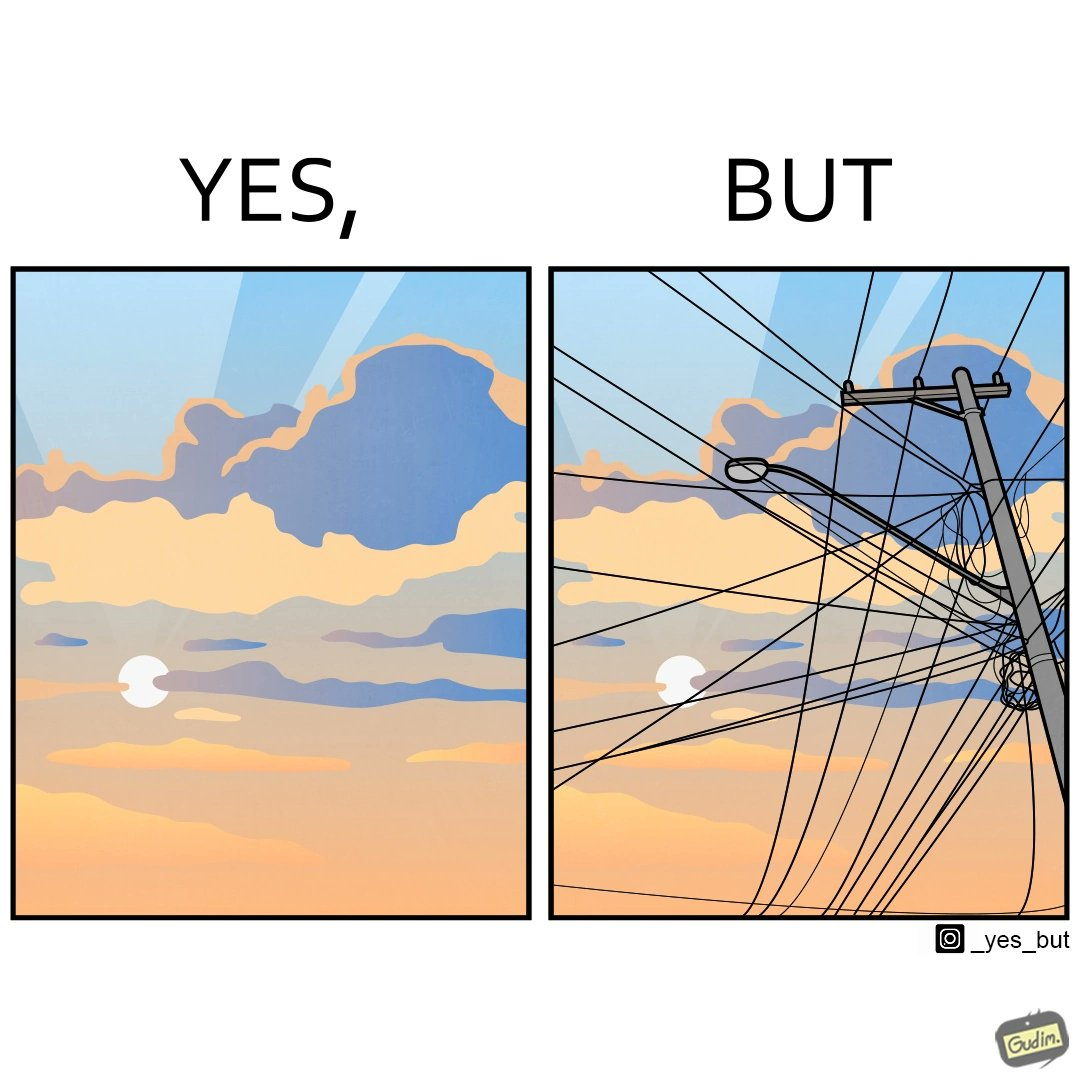What makes this image funny or satirical? The image is ironic, because in the first image clear sky is visible but in the second image the same view is getting blocked due to the electricity pole 